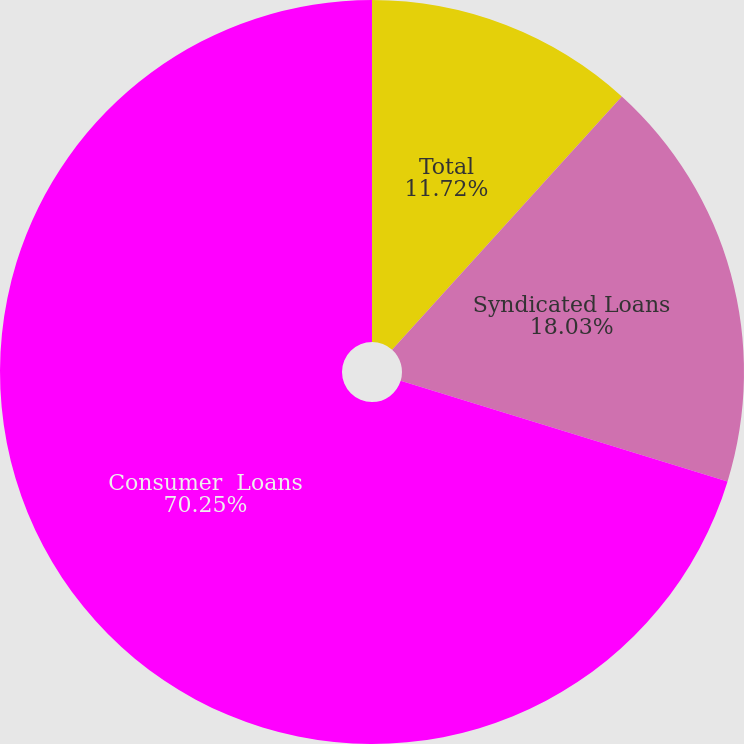Convert chart. <chart><loc_0><loc_0><loc_500><loc_500><pie_chart><fcel>Total<fcel>Syndicated Loans<fcel>Consumer  Loans<nl><fcel>11.72%<fcel>18.03%<fcel>70.25%<nl></chart> 